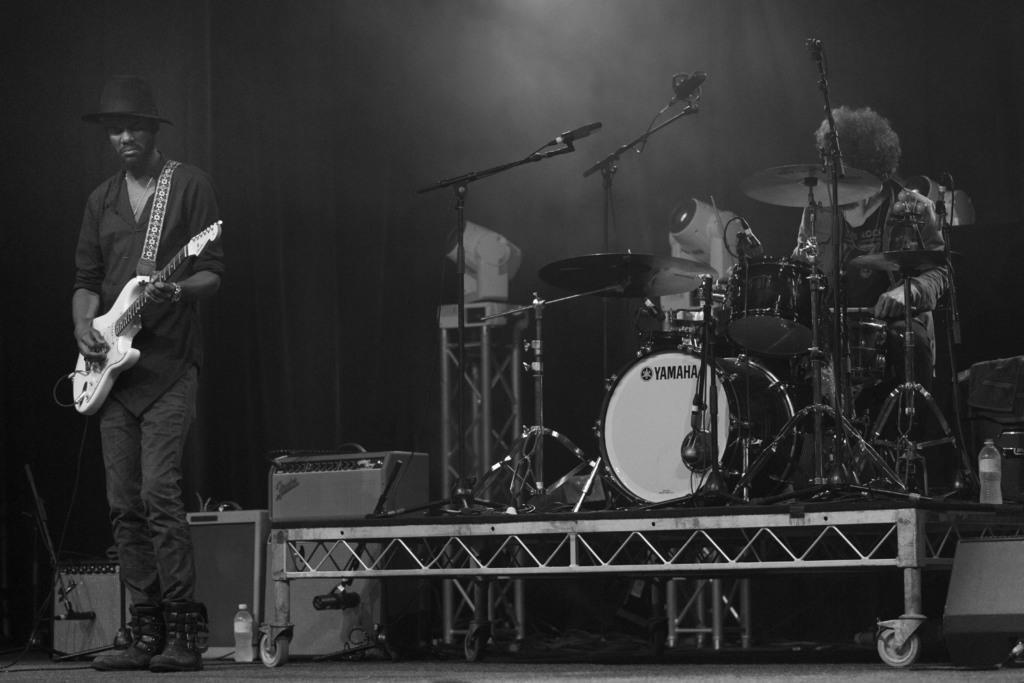Please provide a concise description of this image. There is a man standing with a guitar in his hand and a cap on his head. On the right side we have another man who is playing the musical instruments. There are different types of musical instruments on the left side,there is a mic. There is a drum on the right side and there is a musical plate on right side on the right bottom we can see a bottle. 